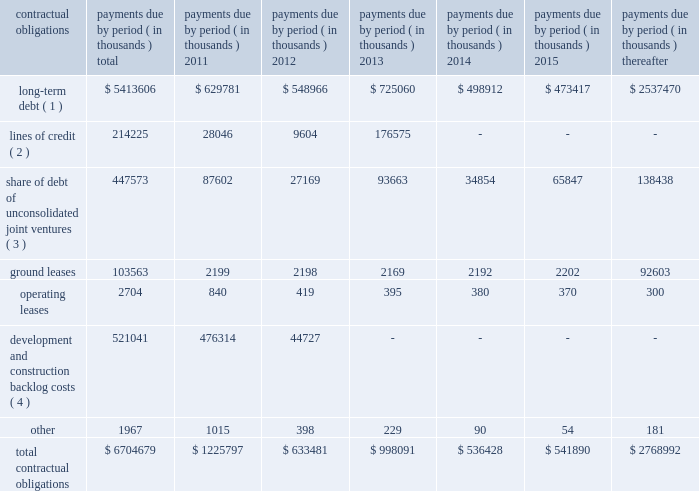39 annual report 2010 duke realty corporation | | related party transactions we provide property and asset management , leasing , construction and other tenant related services to unconsolidated companies in which we have equity interests .
For the years ended december 31 , 2010 , 2009 and 2008 , respectively , we earned management fees of $ 7.6 million , $ 8.4 million and $ 7.8 million , leasing fees of $ 2.7 million , $ 4.2 million and $ 2.8 million and construction and development fees of $ 10.3 million , $ 10.2 million and $ 12.7 million from these companies .
We recorded these fees based on contractual terms that approximate market rates for these types of services , and we have eliminated our ownership percentages of these fees in the consolidated financial statements .
Commitments and contingencies we have guaranteed the repayment of $ 95.4 million of economic development bonds issued by various municipalities in connection with certain commercial developments .
We will be required to make payments under our guarantees to the extent that incremental taxes from specified developments are not sufficient to pay the bond debt service .
Management does not believe that it is probable that we will be required to make any significant payments in satisfaction of these guarantees .
We also have guaranteed the repayment of secured and unsecured loans of six of our unconsolidated subsidiaries .
At december 31 , 2010 , the maximum guarantee exposure for these loans was approximately $ 245.4 million .
With the exception of the guarantee of the debt of 3630 peachtree joint venture , for which we recorded a contingent liability in 2009 of $ 36.3 million , management believes it probable that we will not be required to satisfy these guarantees .
We lease certain land positions with terms extending to december 2080 , with a total obligation of $ 103.6 million .
No payments on these ground leases are material in any individual year .
We are subject to various legal proceedings and claims that arise in the ordinary course of business .
In the opinion of management , the amount of any ultimate liability with respect to these actions will not materially affect our consolidated financial statements or results of operations .
Contractual obligations at december 31 , 2010 , we were subject to certain contractual payment obligations as described in the table below: .
( 1 ) our long-term debt consists of both secured and unsecured debt and includes both principal and interest .
Interest expense for variable rate debt was calculated using the interest rates as of december 31 , 2010 .
( 2 ) our unsecured lines of credit consist of an operating line of credit that matures february 2013 and the line of credit of a consolidated subsidiary that matures july 2011 .
Interest expense for our unsecured lines of credit was calculated using the most recent stated interest rates that were in effect .
( 3 ) our share of unconsolidated joint venture debt includes both principal and interest .
Interest expense for variable rate debt was calculated using the interest rate at december 31 , 2010 .
( 4 ) represents estimated remaining costs on the completion of owned development projects and third-party construction projects. .
What was the total revenues earned in 2016 from managementleasing and construction and development? 
Computations: ((7.6 + 2.7) + (7.6 + 2.7))
Answer: 20.6. 